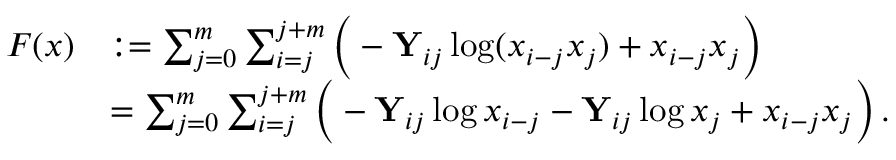Convert formula to latex. <formula><loc_0><loc_0><loc_500><loc_500>\begin{array} { r l } { F ( x ) } & { \colon = \sum _ { j = 0 } ^ { m } \sum _ { i = j } ^ { j + m } \left ( - Y _ { i j } \log ( x _ { i - j } x _ { j } ) + x _ { i - j } x _ { j } \right ) } \\ & { = \sum _ { j = 0 } ^ { m } \sum _ { i = j } ^ { j + m } \left ( - Y _ { i j } \log x _ { i - j } - Y _ { i j } \log x _ { j } + x _ { i - j } x _ { j } \right ) \, . } \end{array}</formula> 